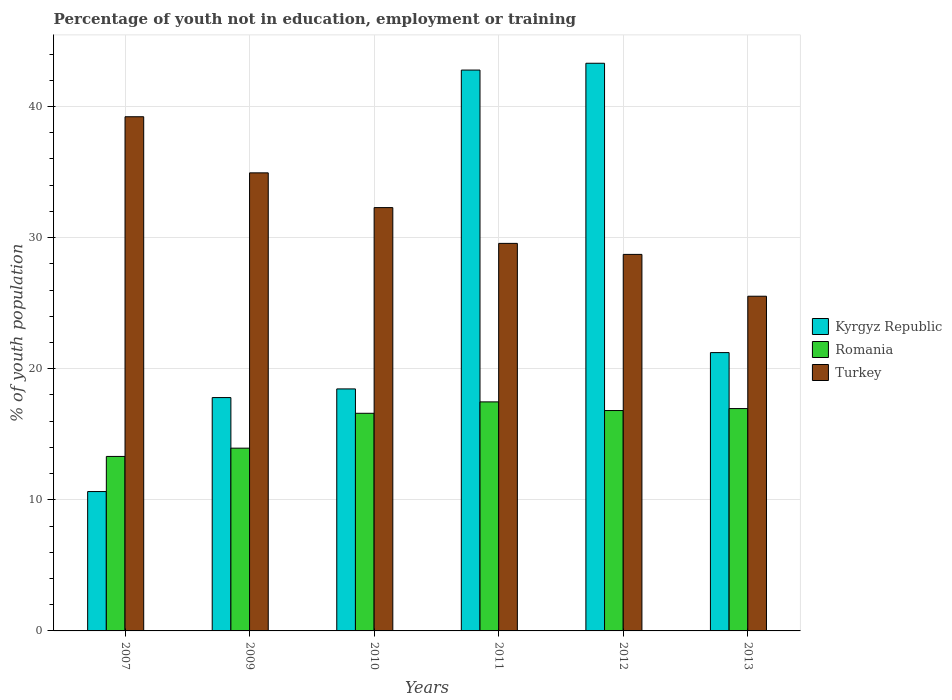How many different coloured bars are there?
Offer a terse response. 3. How many groups of bars are there?
Make the answer very short. 6. Are the number of bars on each tick of the X-axis equal?
Your answer should be very brief. Yes. What is the percentage of unemployed youth population in in Turkey in 2013?
Provide a short and direct response. 25.53. Across all years, what is the maximum percentage of unemployed youth population in in Turkey?
Your answer should be very brief. 39.22. Across all years, what is the minimum percentage of unemployed youth population in in Romania?
Offer a terse response. 13.31. In which year was the percentage of unemployed youth population in in Kyrgyz Republic maximum?
Provide a succinct answer. 2012. In which year was the percentage of unemployed youth population in in Romania minimum?
Make the answer very short. 2007. What is the total percentage of unemployed youth population in in Turkey in the graph?
Give a very brief answer. 190.26. What is the difference between the percentage of unemployed youth population in in Kyrgyz Republic in 2010 and that in 2011?
Provide a succinct answer. -24.32. What is the difference between the percentage of unemployed youth population in in Romania in 2009 and the percentage of unemployed youth population in in Turkey in 2012?
Your answer should be very brief. -14.78. What is the average percentage of unemployed youth population in in Romania per year?
Keep it short and to the point. 15.85. In the year 2010, what is the difference between the percentage of unemployed youth population in in Turkey and percentage of unemployed youth population in in Romania?
Your answer should be very brief. 15.69. In how many years, is the percentage of unemployed youth population in in Turkey greater than 32 %?
Ensure brevity in your answer.  3. What is the ratio of the percentage of unemployed youth population in in Romania in 2011 to that in 2013?
Provide a succinct answer. 1.03. Is the percentage of unemployed youth population in in Turkey in 2012 less than that in 2013?
Ensure brevity in your answer.  No. Is the difference between the percentage of unemployed youth population in in Turkey in 2010 and 2012 greater than the difference between the percentage of unemployed youth population in in Romania in 2010 and 2012?
Offer a very short reply. Yes. What is the difference between the highest and the second highest percentage of unemployed youth population in in Romania?
Give a very brief answer. 0.51. What is the difference between the highest and the lowest percentage of unemployed youth population in in Kyrgyz Republic?
Provide a short and direct response. 32.67. What does the 2nd bar from the left in 2007 represents?
Make the answer very short. Romania. What does the 1st bar from the right in 2010 represents?
Offer a terse response. Turkey. Is it the case that in every year, the sum of the percentage of unemployed youth population in in Kyrgyz Republic and percentage of unemployed youth population in in Romania is greater than the percentage of unemployed youth population in in Turkey?
Your response must be concise. No. How many bars are there?
Your answer should be very brief. 18. Are all the bars in the graph horizontal?
Make the answer very short. No. How many years are there in the graph?
Your answer should be compact. 6. Are the values on the major ticks of Y-axis written in scientific E-notation?
Give a very brief answer. No. Does the graph contain grids?
Provide a succinct answer. Yes. How many legend labels are there?
Your answer should be very brief. 3. How are the legend labels stacked?
Make the answer very short. Vertical. What is the title of the graph?
Your answer should be compact. Percentage of youth not in education, employment or training. Does "Iceland" appear as one of the legend labels in the graph?
Ensure brevity in your answer.  No. What is the label or title of the X-axis?
Ensure brevity in your answer.  Years. What is the label or title of the Y-axis?
Offer a terse response. % of youth population. What is the % of youth population in Kyrgyz Republic in 2007?
Make the answer very short. 10.63. What is the % of youth population in Romania in 2007?
Your answer should be compact. 13.31. What is the % of youth population in Turkey in 2007?
Ensure brevity in your answer.  39.22. What is the % of youth population in Kyrgyz Republic in 2009?
Give a very brief answer. 17.8. What is the % of youth population in Romania in 2009?
Make the answer very short. 13.94. What is the % of youth population of Turkey in 2009?
Your answer should be compact. 34.94. What is the % of youth population of Kyrgyz Republic in 2010?
Offer a very short reply. 18.46. What is the % of youth population in Romania in 2010?
Your answer should be very brief. 16.6. What is the % of youth population of Turkey in 2010?
Keep it short and to the point. 32.29. What is the % of youth population of Kyrgyz Republic in 2011?
Your response must be concise. 42.78. What is the % of youth population in Romania in 2011?
Provide a succinct answer. 17.47. What is the % of youth population in Turkey in 2011?
Offer a very short reply. 29.56. What is the % of youth population of Kyrgyz Republic in 2012?
Offer a very short reply. 43.3. What is the % of youth population in Romania in 2012?
Your response must be concise. 16.81. What is the % of youth population of Turkey in 2012?
Provide a succinct answer. 28.72. What is the % of youth population in Kyrgyz Republic in 2013?
Give a very brief answer. 21.23. What is the % of youth population of Romania in 2013?
Your answer should be very brief. 16.96. What is the % of youth population in Turkey in 2013?
Your response must be concise. 25.53. Across all years, what is the maximum % of youth population in Kyrgyz Republic?
Offer a terse response. 43.3. Across all years, what is the maximum % of youth population of Romania?
Your answer should be very brief. 17.47. Across all years, what is the maximum % of youth population of Turkey?
Your answer should be very brief. 39.22. Across all years, what is the minimum % of youth population in Kyrgyz Republic?
Your response must be concise. 10.63. Across all years, what is the minimum % of youth population in Romania?
Give a very brief answer. 13.31. Across all years, what is the minimum % of youth population in Turkey?
Make the answer very short. 25.53. What is the total % of youth population in Kyrgyz Republic in the graph?
Offer a very short reply. 154.2. What is the total % of youth population of Romania in the graph?
Your answer should be compact. 95.09. What is the total % of youth population in Turkey in the graph?
Provide a succinct answer. 190.26. What is the difference between the % of youth population in Kyrgyz Republic in 2007 and that in 2009?
Provide a short and direct response. -7.17. What is the difference between the % of youth population in Romania in 2007 and that in 2009?
Make the answer very short. -0.63. What is the difference between the % of youth population of Turkey in 2007 and that in 2009?
Offer a very short reply. 4.28. What is the difference between the % of youth population in Kyrgyz Republic in 2007 and that in 2010?
Ensure brevity in your answer.  -7.83. What is the difference between the % of youth population of Romania in 2007 and that in 2010?
Provide a succinct answer. -3.29. What is the difference between the % of youth population of Turkey in 2007 and that in 2010?
Ensure brevity in your answer.  6.93. What is the difference between the % of youth population in Kyrgyz Republic in 2007 and that in 2011?
Give a very brief answer. -32.15. What is the difference between the % of youth population in Romania in 2007 and that in 2011?
Your answer should be compact. -4.16. What is the difference between the % of youth population in Turkey in 2007 and that in 2011?
Your response must be concise. 9.66. What is the difference between the % of youth population of Kyrgyz Republic in 2007 and that in 2012?
Make the answer very short. -32.67. What is the difference between the % of youth population of Romania in 2007 and that in 2012?
Your response must be concise. -3.5. What is the difference between the % of youth population in Turkey in 2007 and that in 2012?
Provide a short and direct response. 10.5. What is the difference between the % of youth population of Romania in 2007 and that in 2013?
Your answer should be very brief. -3.65. What is the difference between the % of youth population of Turkey in 2007 and that in 2013?
Your response must be concise. 13.69. What is the difference between the % of youth population in Kyrgyz Republic in 2009 and that in 2010?
Your response must be concise. -0.66. What is the difference between the % of youth population of Romania in 2009 and that in 2010?
Give a very brief answer. -2.66. What is the difference between the % of youth population in Turkey in 2009 and that in 2010?
Offer a very short reply. 2.65. What is the difference between the % of youth population of Kyrgyz Republic in 2009 and that in 2011?
Your answer should be very brief. -24.98. What is the difference between the % of youth population of Romania in 2009 and that in 2011?
Your answer should be compact. -3.53. What is the difference between the % of youth population of Turkey in 2009 and that in 2011?
Offer a terse response. 5.38. What is the difference between the % of youth population of Kyrgyz Republic in 2009 and that in 2012?
Give a very brief answer. -25.5. What is the difference between the % of youth population of Romania in 2009 and that in 2012?
Give a very brief answer. -2.87. What is the difference between the % of youth population in Turkey in 2009 and that in 2012?
Offer a terse response. 6.22. What is the difference between the % of youth population of Kyrgyz Republic in 2009 and that in 2013?
Your response must be concise. -3.43. What is the difference between the % of youth population of Romania in 2009 and that in 2013?
Provide a short and direct response. -3.02. What is the difference between the % of youth population of Turkey in 2009 and that in 2013?
Ensure brevity in your answer.  9.41. What is the difference between the % of youth population of Kyrgyz Republic in 2010 and that in 2011?
Ensure brevity in your answer.  -24.32. What is the difference between the % of youth population of Romania in 2010 and that in 2011?
Your response must be concise. -0.87. What is the difference between the % of youth population of Turkey in 2010 and that in 2011?
Provide a short and direct response. 2.73. What is the difference between the % of youth population in Kyrgyz Republic in 2010 and that in 2012?
Give a very brief answer. -24.84. What is the difference between the % of youth population in Romania in 2010 and that in 2012?
Your response must be concise. -0.21. What is the difference between the % of youth population of Turkey in 2010 and that in 2012?
Offer a terse response. 3.57. What is the difference between the % of youth population of Kyrgyz Republic in 2010 and that in 2013?
Provide a succinct answer. -2.77. What is the difference between the % of youth population of Romania in 2010 and that in 2013?
Keep it short and to the point. -0.36. What is the difference between the % of youth population in Turkey in 2010 and that in 2013?
Your answer should be compact. 6.76. What is the difference between the % of youth population of Kyrgyz Republic in 2011 and that in 2012?
Your answer should be compact. -0.52. What is the difference between the % of youth population in Romania in 2011 and that in 2012?
Ensure brevity in your answer.  0.66. What is the difference between the % of youth population in Turkey in 2011 and that in 2012?
Make the answer very short. 0.84. What is the difference between the % of youth population in Kyrgyz Republic in 2011 and that in 2013?
Offer a terse response. 21.55. What is the difference between the % of youth population in Romania in 2011 and that in 2013?
Your answer should be compact. 0.51. What is the difference between the % of youth population in Turkey in 2011 and that in 2013?
Keep it short and to the point. 4.03. What is the difference between the % of youth population in Kyrgyz Republic in 2012 and that in 2013?
Your answer should be compact. 22.07. What is the difference between the % of youth population of Turkey in 2012 and that in 2013?
Provide a succinct answer. 3.19. What is the difference between the % of youth population of Kyrgyz Republic in 2007 and the % of youth population of Romania in 2009?
Give a very brief answer. -3.31. What is the difference between the % of youth population in Kyrgyz Republic in 2007 and the % of youth population in Turkey in 2009?
Your answer should be compact. -24.31. What is the difference between the % of youth population in Romania in 2007 and the % of youth population in Turkey in 2009?
Make the answer very short. -21.63. What is the difference between the % of youth population in Kyrgyz Republic in 2007 and the % of youth population in Romania in 2010?
Offer a terse response. -5.97. What is the difference between the % of youth population of Kyrgyz Republic in 2007 and the % of youth population of Turkey in 2010?
Offer a terse response. -21.66. What is the difference between the % of youth population in Romania in 2007 and the % of youth population in Turkey in 2010?
Your answer should be very brief. -18.98. What is the difference between the % of youth population of Kyrgyz Republic in 2007 and the % of youth population of Romania in 2011?
Offer a terse response. -6.84. What is the difference between the % of youth population in Kyrgyz Republic in 2007 and the % of youth population in Turkey in 2011?
Offer a very short reply. -18.93. What is the difference between the % of youth population of Romania in 2007 and the % of youth population of Turkey in 2011?
Make the answer very short. -16.25. What is the difference between the % of youth population in Kyrgyz Republic in 2007 and the % of youth population in Romania in 2012?
Your response must be concise. -6.18. What is the difference between the % of youth population in Kyrgyz Republic in 2007 and the % of youth population in Turkey in 2012?
Provide a short and direct response. -18.09. What is the difference between the % of youth population of Romania in 2007 and the % of youth population of Turkey in 2012?
Make the answer very short. -15.41. What is the difference between the % of youth population of Kyrgyz Republic in 2007 and the % of youth population of Romania in 2013?
Your response must be concise. -6.33. What is the difference between the % of youth population in Kyrgyz Republic in 2007 and the % of youth population in Turkey in 2013?
Give a very brief answer. -14.9. What is the difference between the % of youth population of Romania in 2007 and the % of youth population of Turkey in 2013?
Ensure brevity in your answer.  -12.22. What is the difference between the % of youth population in Kyrgyz Republic in 2009 and the % of youth population in Turkey in 2010?
Keep it short and to the point. -14.49. What is the difference between the % of youth population of Romania in 2009 and the % of youth population of Turkey in 2010?
Ensure brevity in your answer.  -18.35. What is the difference between the % of youth population in Kyrgyz Republic in 2009 and the % of youth population in Romania in 2011?
Ensure brevity in your answer.  0.33. What is the difference between the % of youth population of Kyrgyz Republic in 2009 and the % of youth population of Turkey in 2011?
Offer a very short reply. -11.76. What is the difference between the % of youth population of Romania in 2009 and the % of youth population of Turkey in 2011?
Offer a terse response. -15.62. What is the difference between the % of youth population in Kyrgyz Republic in 2009 and the % of youth population in Turkey in 2012?
Your answer should be compact. -10.92. What is the difference between the % of youth population in Romania in 2009 and the % of youth population in Turkey in 2012?
Your response must be concise. -14.78. What is the difference between the % of youth population of Kyrgyz Republic in 2009 and the % of youth population of Romania in 2013?
Your response must be concise. 0.84. What is the difference between the % of youth population of Kyrgyz Republic in 2009 and the % of youth population of Turkey in 2013?
Keep it short and to the point. -7.73. What is the difference between the % of youth population in Romania in 2009 and the % of youth population in Turkey in 2013?
Your response must be concise. -11.59. What is the difference between the % of youth population in Kyrgyz Republic in 2010 and the % of youth population in Romania in 2011?
Your answer should be compact. 0.99. What is the difference between the % of youth population in Kyrgyz Republic in 2010 and the % of youth population in Turkey in 2011?
Offer a terse response. -11.1. What is the difference between the % of youth population of Romania in 2010 and the % of youth population of Turkey in 2011?
Provide a succinct answer. -12.96. What is the difference between the % of youth population of Kyrgyz Republic in 2010 and the % of youth population of Romania in 2012?
Offer a very short reply. 1.65. What is the difference between the % of youth population of Kyrgyz Republic in 2010 and the % of youth population of Turkey in 2012?
Give a very brief answer. -10.26. What is the difference between the % of youth population in Romania in 2010 and the % of youth population in Turkey in 2012?
Provide a succinct answer. -12.12. What is the difference between the % of youth population in Kyrgyz Republic in 2010 and the % of youth population in Romania in 2013?
Provide a short and direct response. 1.5. What is the difference between the % of youth population in Kyrgyz Republic in 2010 and the % of youth population in Turkey in 2013?
Provide a succinct answer. -7.07. What is the difference between the % of youth population in Romania in 2010 and the % of youth population in Turkey in 2013?
Your answer should be compact. -8.93. What is the difference between the % of youth population in Kyrgyz Republic in 2011 and the % of youth population in Romania in 2012?
Make the answer very short. 25.97. What is the difference between the % of youth population of Kyrgyz Republic in 2011 and the % of youth population of Turkey in 2012?
Provide a short and direct response. 14.06. What is the difference between the % of youth population of Romania in 2011 and the % of youth population of Turkey in 2012?
Your answer should be compact. -11.25. What is the difference between the % of youth population of Kyrgyz Republic in 2011 and the % of youth population of Romania in 2013?
Provide a short and direct response. 25.82. What is the difference between the % of youth population in Kyrgyz Republic in 2011 and the % of youth population in Turkey in 2013?
Provide a short and direct response. 17.25. What is the difference between the % of youth population of Romania in 2011 and the % of youth population of Turkey in 2013?
Your answer should be very brief. -8.06. What is the difference between the % of youth population of Kyrgyz Republic in 2012 and the % of youth population of Romania in 2013?
Your answer should be very brief. 26.34. What is the difference between the % of youth population in Kyrgyz Republic in 2012 and the % of youth population in Turkey in 2013?
Make the answer very short. 17.77. What is the difference between the % of youth population of Romania in 2012 and the % of youth population of Turkey in 2013?
Provide a short and direct response. -8.72. What is the average % of youth population in Kyrgyz Republic per year?
Make the answer very short. 25.7. What is the average % of youth population of Romania per year?
Your answer should be very brief. 15.85. What is the average % of youth population of Turkey per year?
Your answer should be very brief. 31.71. In the year 2007, what is the difference between the % of youth population of Kyrgyz Republic and % of youth population of Romania?
Provide a short and direct response. -2.68. In the year 2007, what is the difference between the % of youth population in Kyrgyz Republic and % of youth population in Turkey?
Give a very brief answer. -28.59. In the year 2007, what is the difference between the % of youth population in Romania and % of youth population in Turkey?
Provide a short and direct response. -25.91. In the year 2009, what is the difference between the % of youth population in Kyrgyz Republic and % of youth population in Romania?
Give a very brief answer. 3.86. In the year 2009, what is the difference between the % of youth population in Kyrgyz Republic and % of youth population in Turkey?
Give a very brief answer. -17.14. In the year 2010, what is the difference between the % of youth population of Kyrgyz Republic and % of youth population of Romania?
Provide a short and direct response. 1.86. In the year 2010, what is the difference between the % of youth population in Kyrgyz Republic and % of youth population in Turkey?
Your answer should be very brief. -13.83. In the year 2010, what is the difference between the % of youth population in Romania and % of youth population in Turkey?
Provide a short and direct response. -15.69. In the year 2011, what is the difference between the % of youth population of Kyrgyz Republic and % of youth population of Romania?
Provide a short and direct response. 25.31. In the year 2011, what is the difference between the % of youth population of Kyrgyz Republic and % of youth population of Turkey?
Offer a very short reply. 13.22. In the year 2011, what is the difference between the % of youth population of Romania and % of youth population of Turkey?
Keep it short and to the point. -12.09. In the year 2012, what is the difference between the % of youth population in Kyrgyz Republic and % of youth population in Romania?
Keep it short and to the point. 26.49. In the year 2012, what is the difference between the % of youth population in Kyrgyz Republic and % of youth population in Turkey?
Offer a terse response. 14.58. In the year 2012, what is the difference between the % of youth population of Romania and % of youth population of Turkey?
Your answer should be very brief. -11.91. In the year 2013, what is the difference between the % of youth population of Kyrgyz Republic and % of youth population of Romania?
Keep it short and to the point. 4.27. In the year 2013, what is the difference between the % of youth population of Kyrgyz Republic and % of youth population of Turkey?
Provide a short and direct response. -4.3. In the year 2013, what is the difference between the % of youth population of Romania and % of youth population of Turkey?
Your response must be concise. -8.57. What is the ratio of the % of youth population in Kyrgyz Republic in 2007 to that in 2009?
Offer a terse response. 0.6. What is the ratio of the % of youth population in Romania in 2007 to that in 2009?
Provide a short and direct response. 0.95. What is the ratio of the % of youth population of Turkey in 2007 to that in 2009?
Provide a succinct answer. 1.12. What is the ratio of the % of youth population in Kyrgyz Republic in 2007 to that in 2010?
Offer a terse response. 0.58. What is the ratio of the % of youth population in Romania in 2007 to that in 2010?
Make the answer very short. 0.8. What is the ratio of the % of youth population in Turkey in 2007 to that in 2010?
Keep it short and to the point. 1.21. What is the ratio of the % of youth population of Kyrgyz Republic in 2007 to that in 2011?
Offer a very short reply. 0.25. What is the ratio of the % of youth population in Romania in 2007 to that in 2011?
Offer a terse response. 0.76. What is the ratio of the % of youth population of Turkey in 2007 to that in 2011?
Ensure brevity in your answer.  1.33. What is the ratio of the % of youth population of Kyrgyz Republic in 2007 to that in 2012?
Provide a short and direct response. 0.25. What is the ratio of the % of youth population of Romania in 2007 to that in 2012?
Provide a succinct answer. 0.79. What is the ratio of the % of youth population in Turkey in 2007 to that in 2012?
Your answer should be compact. 1.37. What is the ratio of the % of youth population of Kyrgyz Republic in 2007 to that in 2013?
Offer a terse response. 0.5. What is the ratio of the % of youth population of Romania in 2007 to that in 2013?
Offer a terse response. 0.78. What is the ratio of the % of youth population of Turkey in 2007 to that in 2013?
Provide a short and direct response. 1.54. What is the ratio of the % of youth population of Kyrgyz Republic in 2009 to that in 2010?
Keep it short and to the point. 0.96. What is the ratio of the % of youth population of Romania in 2009 to that in 2010?
Ensure brevity in your answer.  0.84. What is the ratio of the % of youth population of Turkey in 2009 to that in 2010?
Offer a very short reply. 1.08. What is the ratio of the % of youth population of Kyrgyz Republic in 2009 to that in 2011?
Keep it short and to the point. 0.42. What is the ratio of the % of youth population of Romania in 2009 to that in 2011?
Make the answer very short. 0.8. What is the ratio of the % of youth population in Turkey in 2009 to that in 2011?
Ensure brevity in your answer.  1.18. What is the ratio of the % of youth population in Kyrgyz Republic in 2009 to that in 2012?
Provide a short and direct response. 0.41. What is the ratio of the % of youth population of Romania in 2009 to that in 2012?
Your answer should be very brief. 0.83. What is the ratio of the % of youth population of Turkey in 2009 to that in 2012?
Ensure brevity in your answer.  1.22. What is the ratio of the % of youth population in Kyrgyz Republic in 2009 to that in 2013?
Ensure brevity in your answer.  0.84. What is the ratio of the % of youth population of Romania in 2009 to that in 2013?
Give a very brief answer. 0.82. What is the ratio of the % of youth population in Turkey in 2009 to that in 2013?
Offer a very short reply. 1.37. What is the ratio of the % of youth population of Kyrgyz Republic in 2010 to that in 2011?
Offer a terse response. 0.43. What is the ratio of the % of youth population of Romania in 2010 to that in 2011?
Your answer should be compact. 0.95. What is the ratio of the % of youth population of Turkey in 2010 to that in 2011?
Offer a terse response. 1.09. What is the ratio of the % of youth population in Kyrgyz Republic in 2010 to that in 2012?
Ensure brevity in your answer.  0.43. What is the ratio of the % of youth population in Romania in 2010 to that in 2012?
Keep it short and to the point. 0.99. What is the ratio of the % of youth population in Turkey in 2010 to that in 2012?
Provide a succinct answer. 1.12. What is the ratio of the % of youth population in Kyrgyz Republic in 2010 to that in 2013?
Provide a succinct answer. 0.87. What is the ratio of the % of youth population of Romania in 2010 to that in 2013?
Offer a very short reply. 0.98. What is the ratio of the % of youth population in Turkey in 2010 to that in 2013?
Your answer should be very brief. 1.26. What is the ratio of the % of youth population of Romania in 2011 to that in 2012?
Give a very brief answer. 1.04. What is the ratio of the % of youth population of Turkey in 2011 to that in 2012?
Offer a terse response. 1.03. What is the ratio of the % of youth population of Kyrgyz Republic in 2011 to that in 2013?
Your answer should be very brief. 2.02. What is the ratio of the % of youth population of Romania in 2011 to that in 2013?
Provide a short and direct response. 1.03. What is the ratio of the % of youth population of Turkey in 2011 to that in 2013?
Provide a succinct answer. 1.16. What is the ratio of the % of youth population in Kyrgyz Republic in 2012 to that in 2013?
Offer a very short reply. 2.04. What is the ratio of the % of youth population of Romania in 2012 to that in 2013?
Offer a terse response. 0.99. What is the difference between the highest and the second highest % of youth population in Kyrgyz Republic?
Offer a terse response. 0.52. What is the difference between the highest and the second highest % of youth population of Romania?
Provide a short and direct response. 0.51. What is the difference between the highest and the second highest % of youth population of Turkey?
Provide a succinct answer. 4.28. What is the difference between the highest and the lowest % of youth population of Kyrgyz Republic?
Your response must be concise. 32.67. What is the difference between the highest and the lowest % of youth population in Romania?
Your response must be concise. 4.16. What is the difference between the highest and the lowest % of youth population of Turkey?
Offer a very short reply. 13.69. 